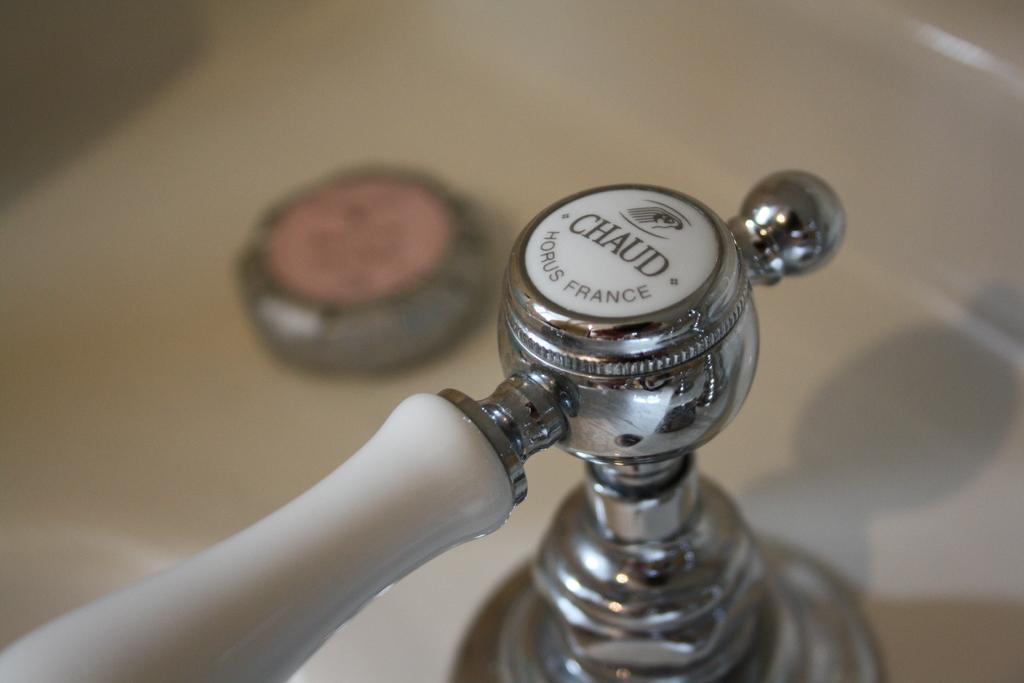Describe this image in one or two sentences. In the center of the image there is a sink and we can see a tap. 